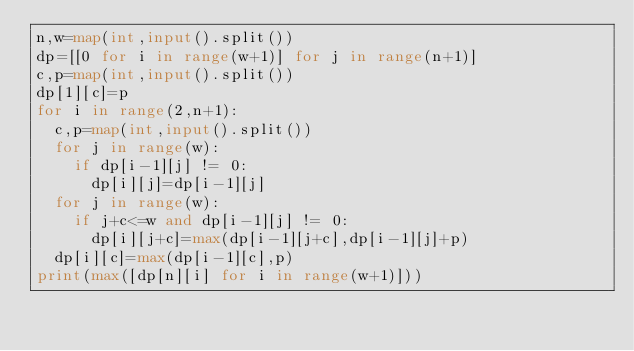Convert code to text. <code><loc_0><loc_0><loc_500><loc_500><_Python_>n,w=map(int,input().split())
dp=[[0 for i in range(w+1)] for j in range(n+1)]
c,p=map(int,input().split())
dp[1][c]=p
for i in range(2,n+1):
  c,p=map(int,input().split())
  for j in range(w):
    if dp[i-1][j] != 0:
      dp[i][j]=dp[i-1][j]
  for j in range(w):
    if j+c<=w and dp[i-1][j] != 0:
      dp[i][j+c]=max(dp[i-1][j+c],dp[i-1][j]+p)
  dp[i][c]=max(dp[i-1][c],p)
print(max([dp[n][i] for i in range(w+1)]))</code> 